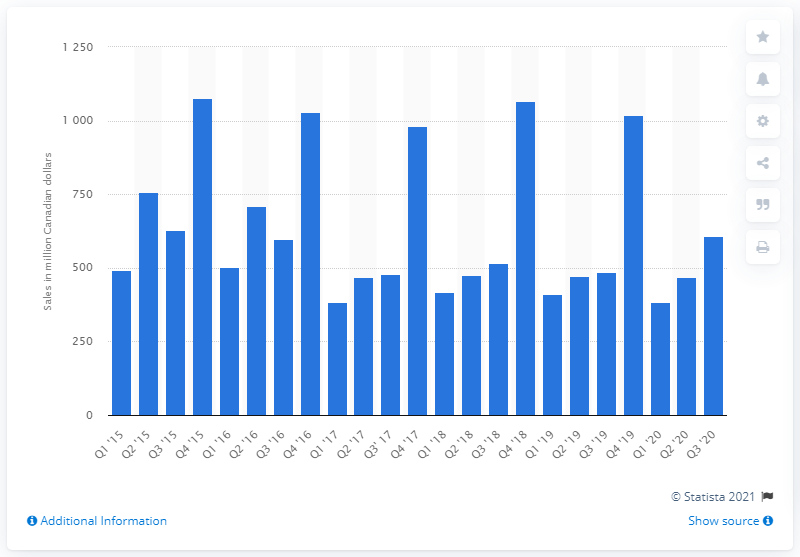Highlight a few significant elements in this photo. In the third quarter of 2020, the sales of toys, games, and hobby supplies in Canada amounted to CAD 596.67. 